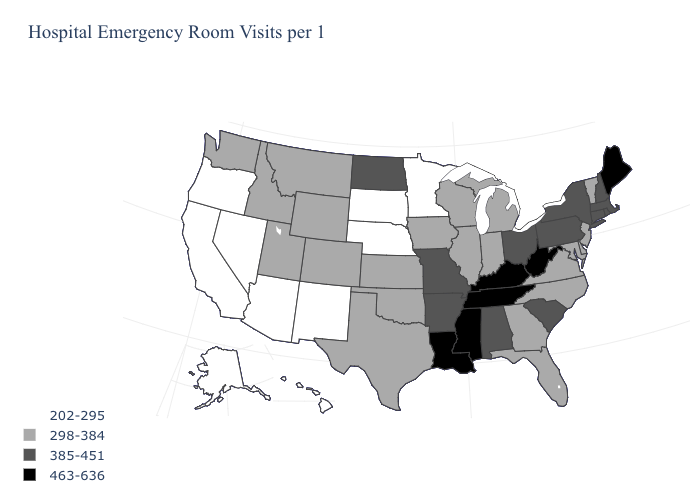What is the value of Ohio?
Write a very short answer. 385-451. Is the legend a continuous bar?
Answer briefly. No. Which states have the lowest value in the Northeast?
Give a very brief answer. New Jersey, Vermont. Does Colorado have the highest value in the West?
Concise answer only. Yes. What is the lowest value in the West?
Answer briefly. 202-295. What is the lowest value in the South?
Keep it brief. 298-384. Does Massachusetts have a higher value than Rhode Island?
Give a very brief answer. No. Name the states that have a value in the range 463-636?
Short answer required. Kentucky, Louisiana, Maine, Mississippi, Tennessee, West Virginia. What is the value of Arkansas?
Quick response, please. 385-451. Which states have the lowest value in the USA?
Answer briefly. Alaska, Arizona, California, Hawaii, Minnesota, Nebraska, Nevada, New Mexico, Oregon, South Dakota. Name the states that have a value in the range 463-636?
Answer briefly. Kentucky, Louisiana, Maine, Mississippi, Tennessee, West Virginia. What is the highest value in the USA?
Give a very brief answer. 463-636. What is the value of Maine?
Answer briefly. 463-636. Name the states that have a value in the range 463-636?
Answer briefly. Kentucky, Louisiana, Maine, Mississippi, Tennessee, West Virginia. 